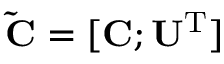<formula> <loc_0><loc_0><loc_500><loc_500>\tilde { C } = [ C ; U ^ { T } ]</formula> 